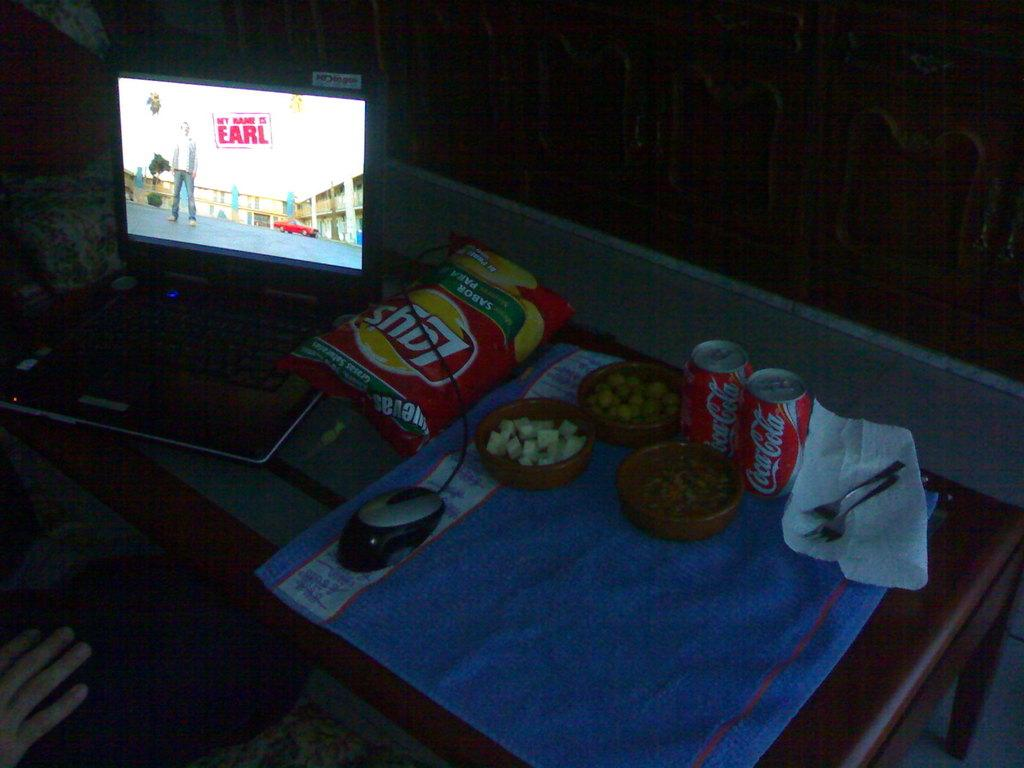<image>
Render a clear and concise summary of the photo. snacks on a table including Lays chips and Coca Cola 